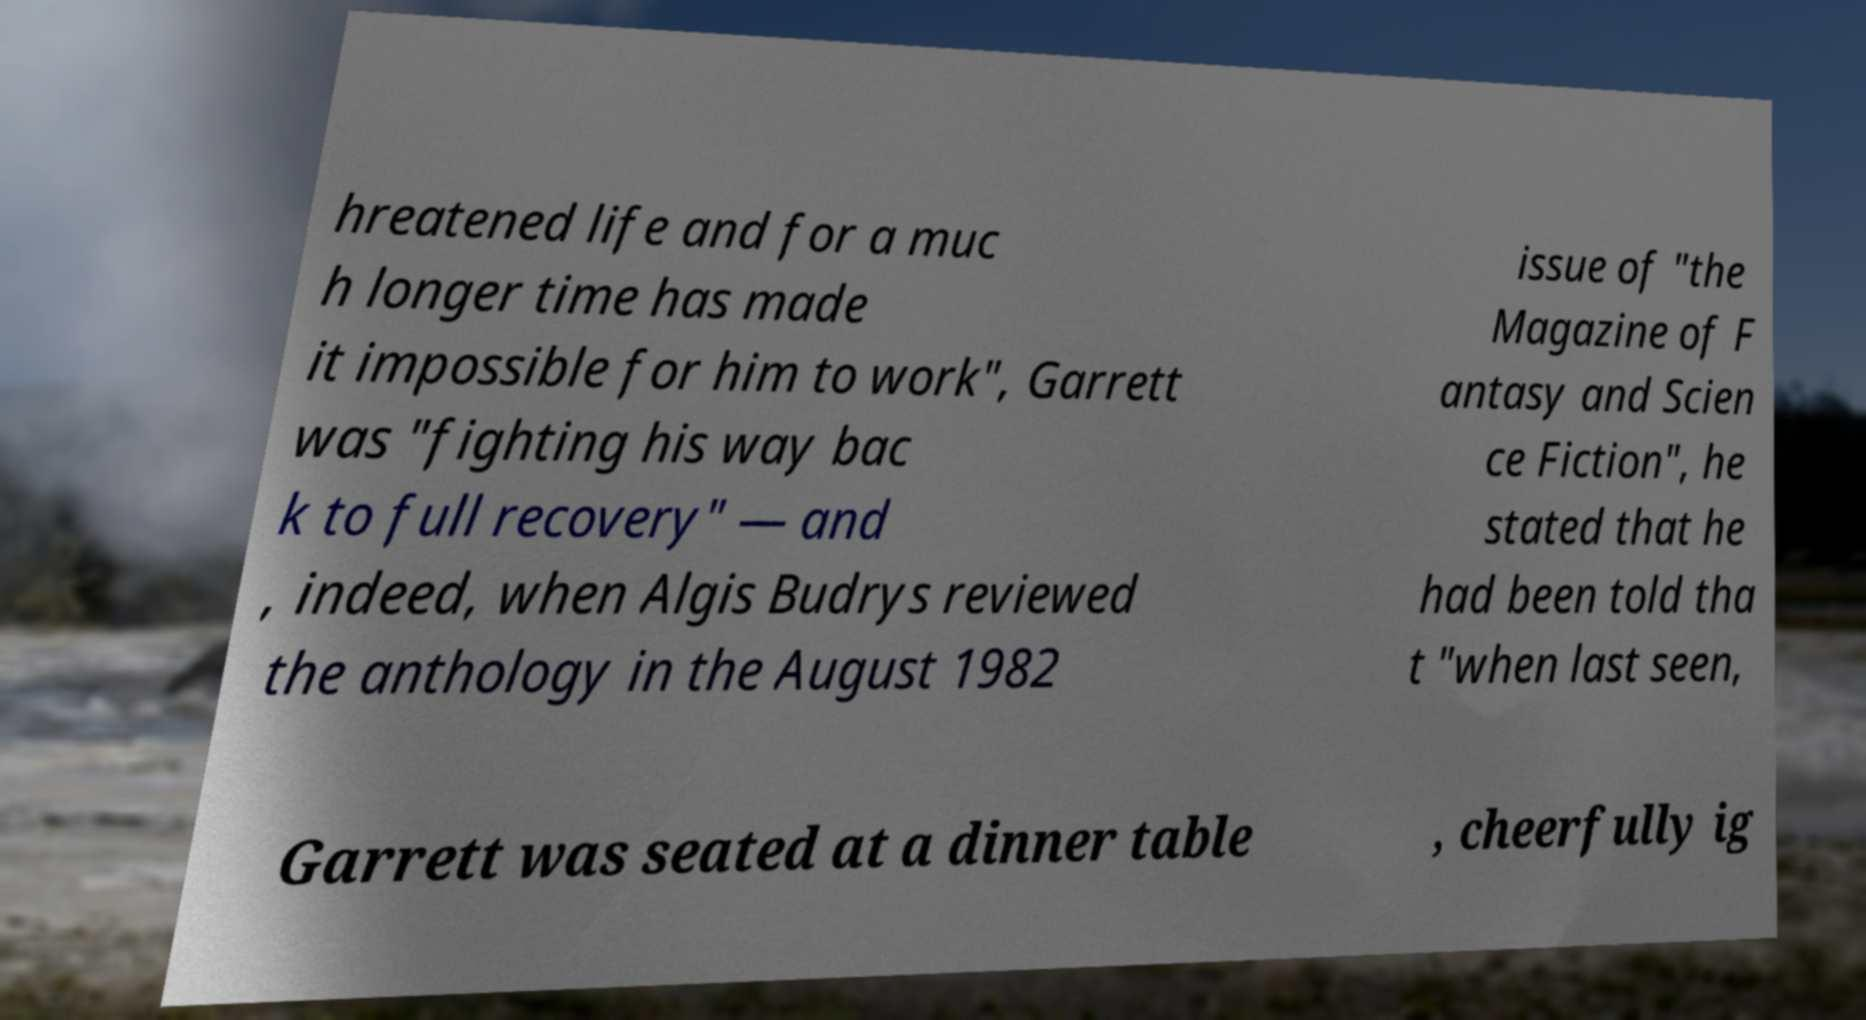Can you accurately transcribe the text from the provided image for me? hreatened life and for a muc h longer time has made it impossible for him to work", Garrett was "fighting his way bac k to full recovery" — and , indeed, when Algis Budrys reviewed the anthology in the August 1982 issue of "the Magazine of F antasy and Scien ce Fiction", he stated that he had been told tha t "when last seen, Garrett was seated at a dinner table , cheerfully ig 